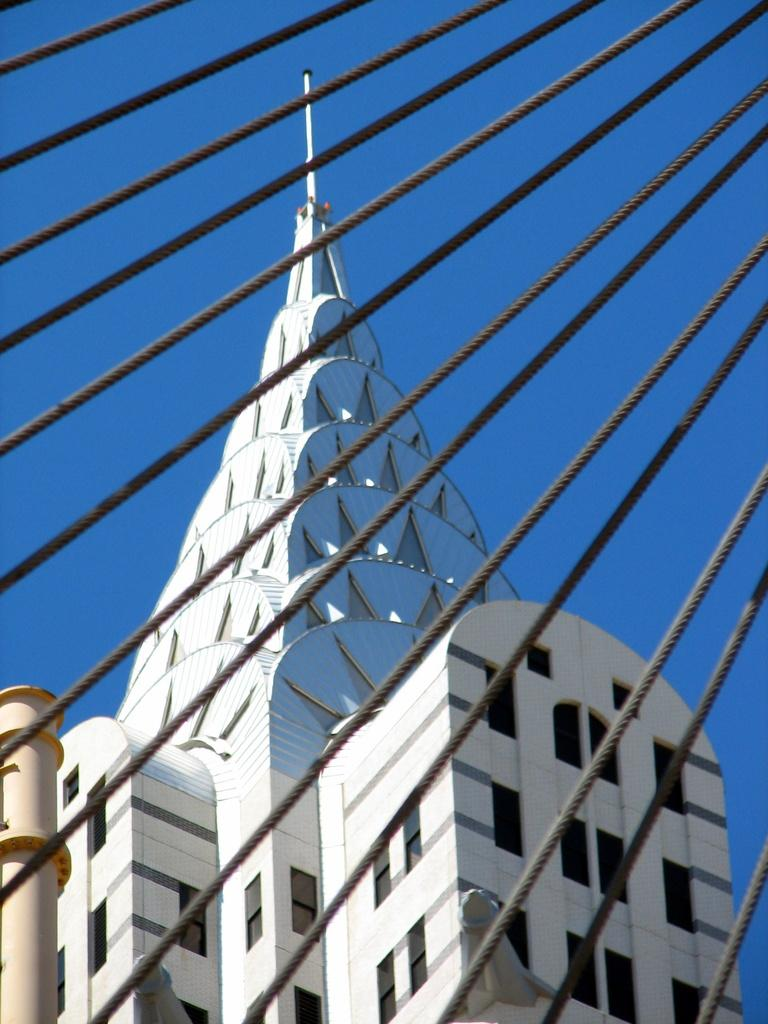What type of structure is depicted in the image? There is a tower or multi-story building in the image. What other objects can be seen in the image? There are poles arranged parallel in the image. What is visible at the top of the image? The sky is visible at the top of the image. Where is the spade located in the image? There is no spade present in the image. What type of food is being served in the lunchroom in the image? There is no lunchroom present in the image. 